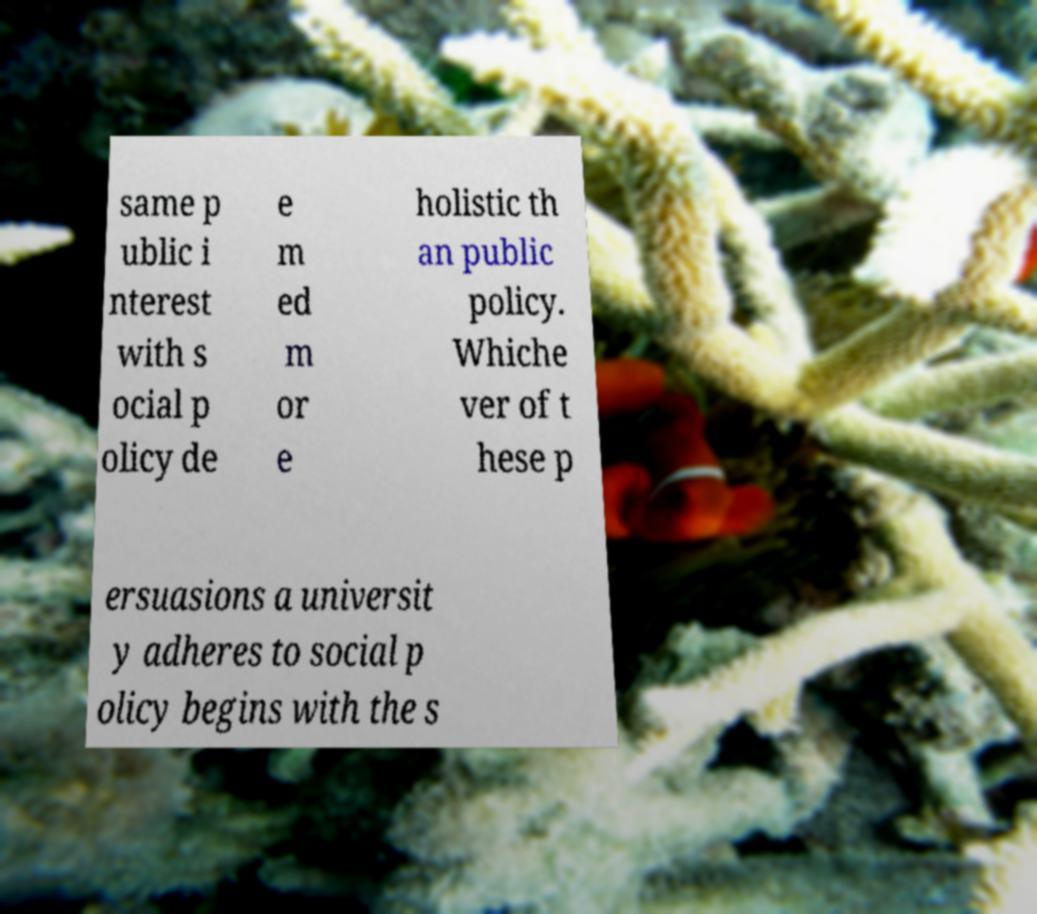Can you read and provide the text displayed in the image?This photo seems to have some interesting text. Can you extract and type it out for me? same p ublic i nterest with s ocial p olicy de e m ed m or e holistic th an public policy. Whiche ver of t hese p ersuasions a universit y adheres to social p olicy begins with the s 